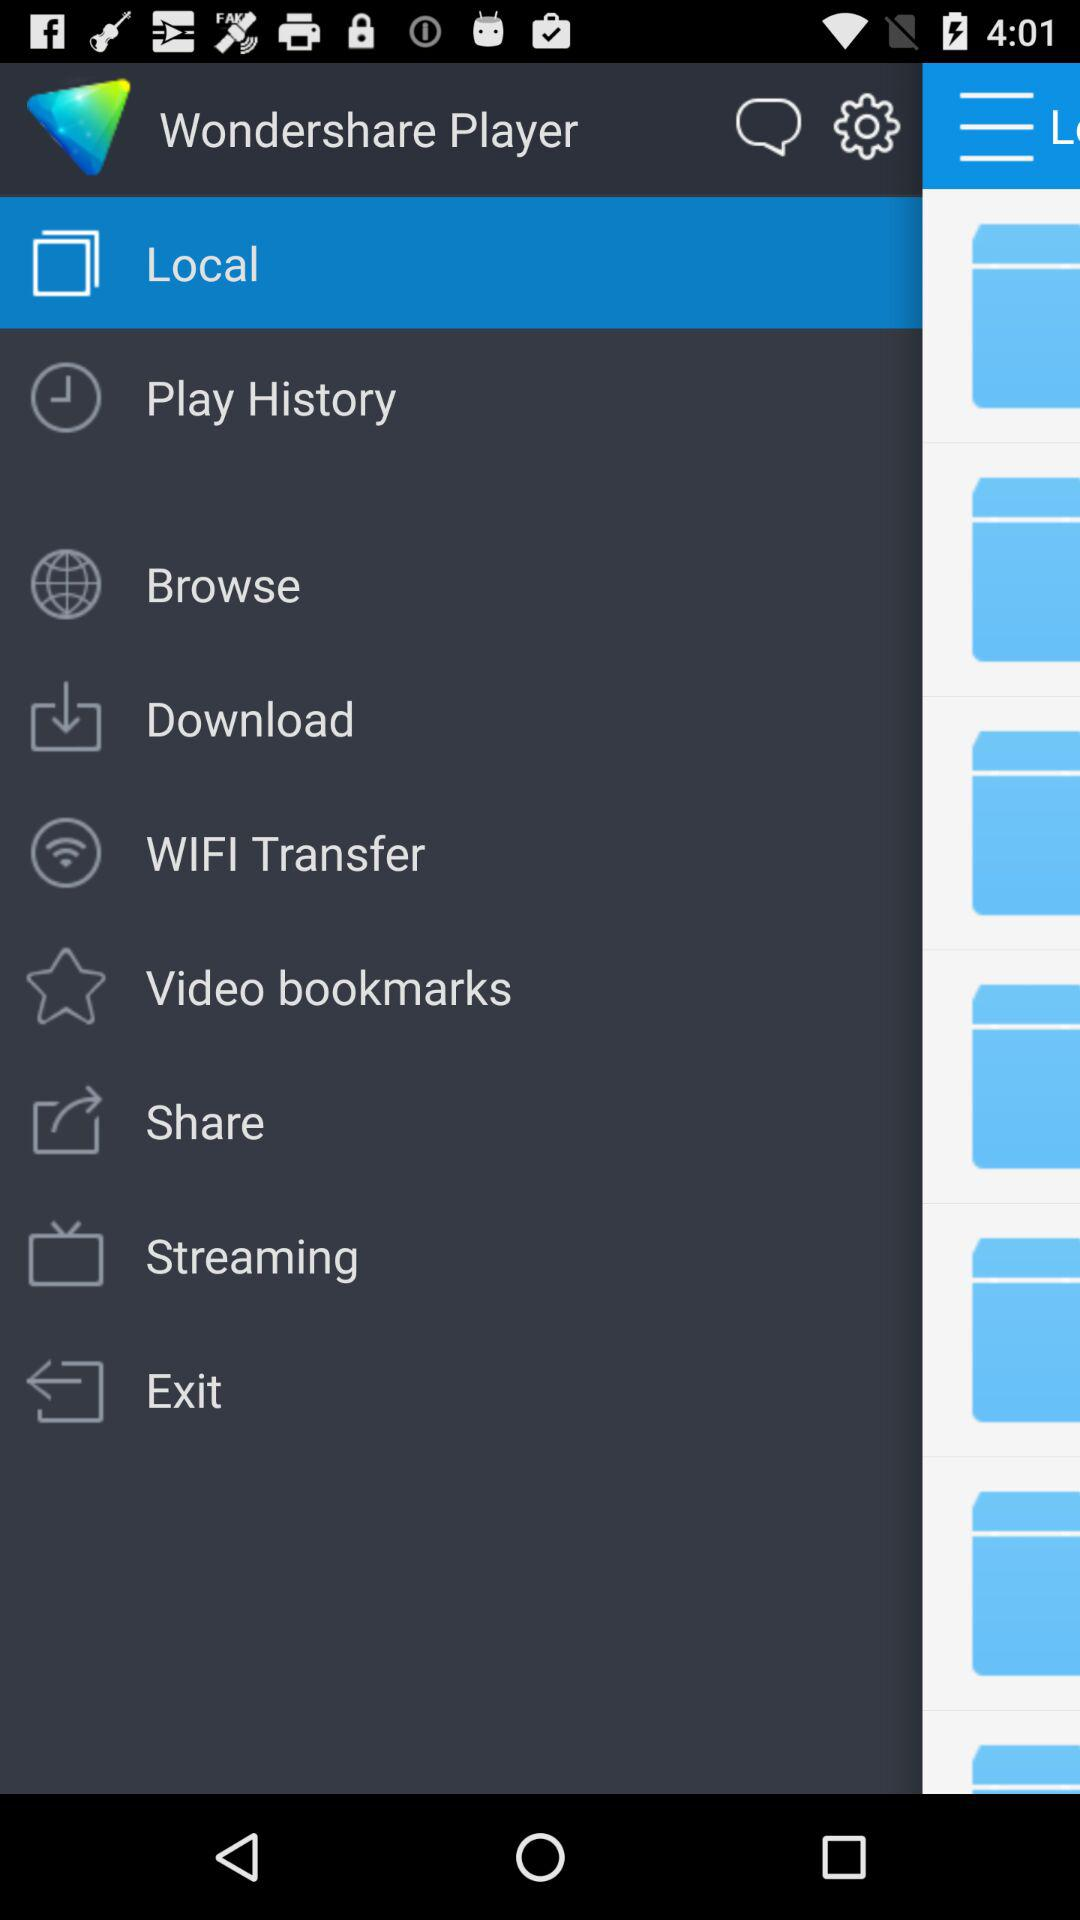What is the application name? The application name is "Wondershare Player". 